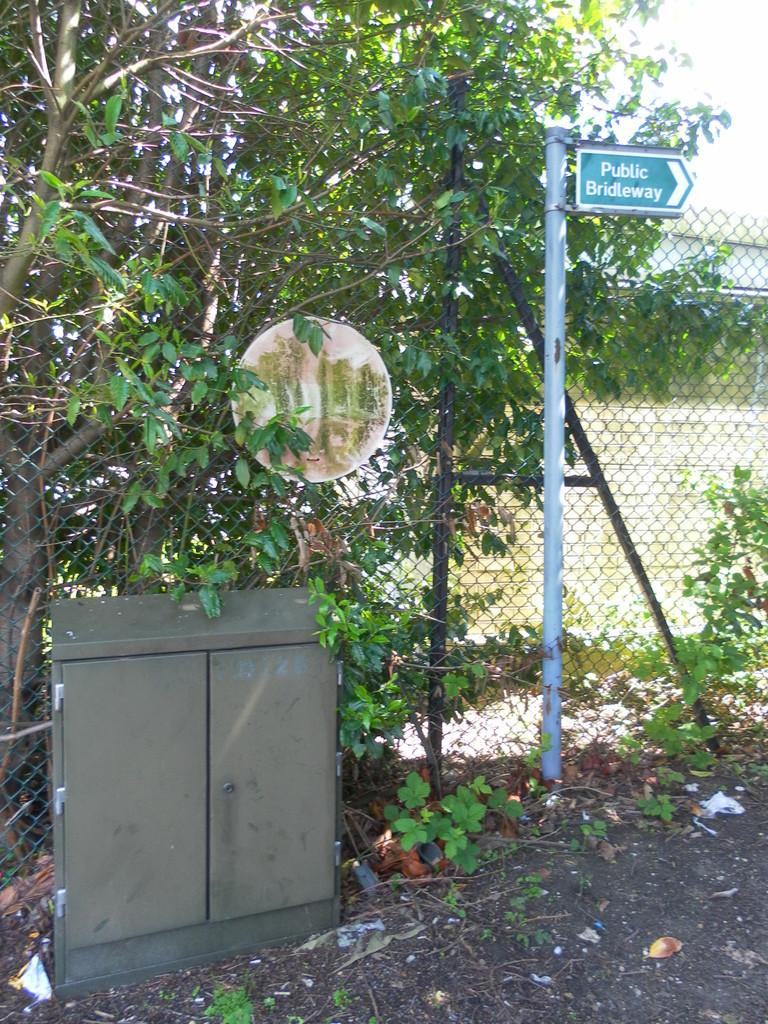What is the main structure in the image? There is a board with a pole in the image. What type of object has doors in the image? There is a box with doors in the image. What type of vegetation is present in the image? There are plants and trees in the image. What type of barrier is present in the image? There is a wire fence in the image. What is visible in the background of the image? The sky is visible in the background of the image. What type of dinner is being served in the image? There is no dinner present in the image; it features a board with a pole, a box with doors, plants, trees, a wire fence, and the sky in the background. What type of office furniture is visible in the image? There is no office furniture present in the image. 